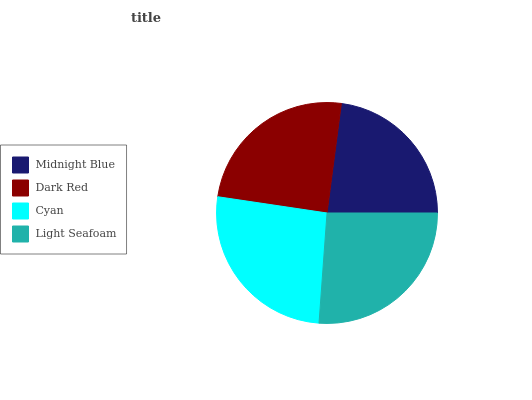Is Midnight Blue the minimum?
Answer yes or no. Yes. Is Cyan the maximum?
Answer yes or no. Yes. Is Dark Red the minimum?
Answer yes or no. No. Is Dark Red the maximum?
Answer yes or no. No. Is Dark Red greater than Midnight Blue?
Answer yes or no. Yes. Is Midnight Blue less than Dark Red?
Answer yes or no. Yes. Is Midnight Blue greater than Dark Red?
Answer yes or no. No. Is Dark Red less than Midnight Blue?
Answer yes or no. No. Is Light Seafoam the high median?
Answer yes or no. Yes. Is Dark Red the low median?
Answer yes or no. Yes. Is Dark Red the high median?
Answer yes or no. No. Is Midnight Blue the low median?
Answer yes or no. No. 